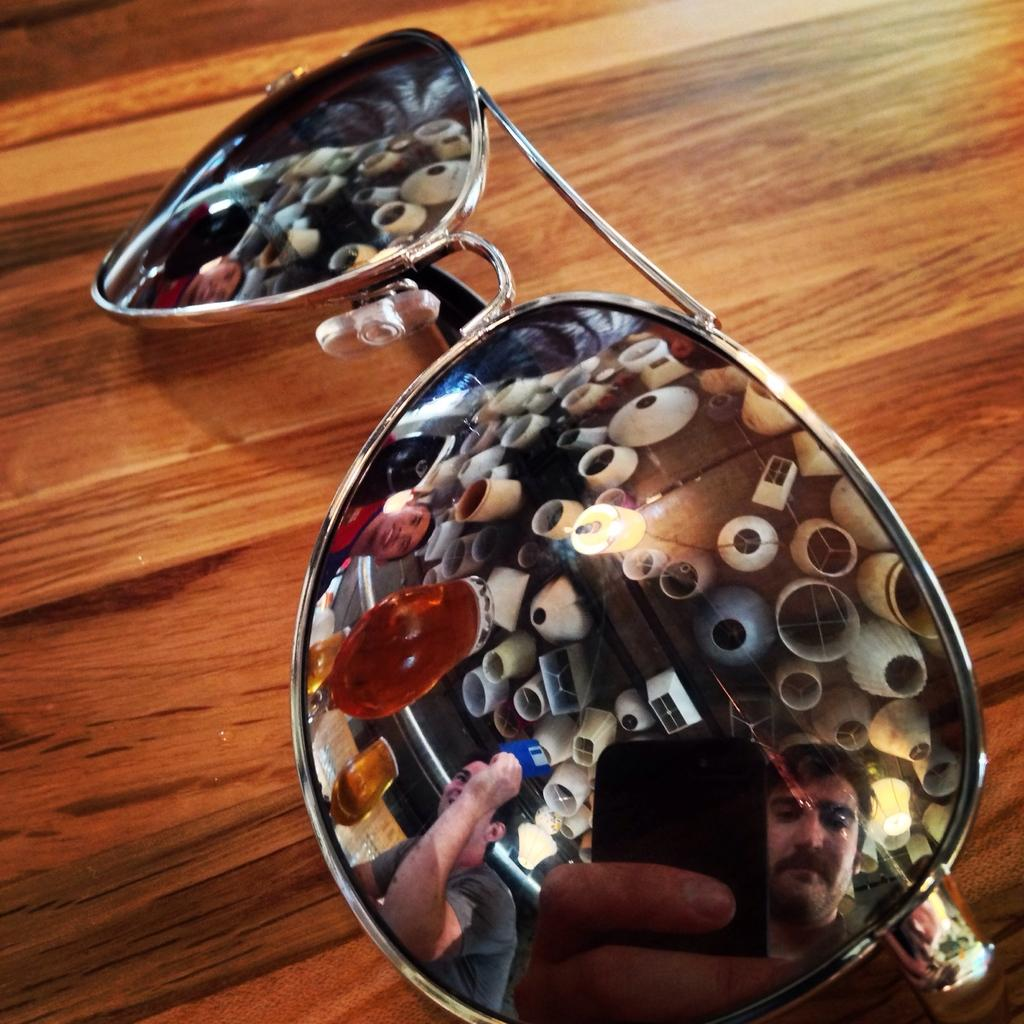What is placed on the table in the image? There are goggles on the table. What can be seen in the reflection of the goggles? The reflection includes persons, glasses, and lights. Can you describe the type of glasses visible in the reflection? The reflection shows glasses, but the specific type cannot be determined from the image. What type of collar can be seen on the mine in the image? There is no mine or collar present in the image; it features goggles with a reflection of persons, glasses, and lights. 